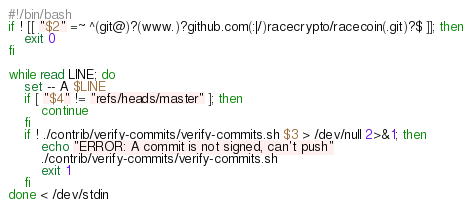Convert code to text. <code><loc_0><loc_0><loc_500><loc_500><_Bash_>#!/bin/bash
if ! [[ "$2" =~ ^(git@)?(www.)?github.com(:|/)racecrypto/racecoin(.git)?$ ]]; then
    exit 0
fi

while read LINE; do
    set -- A $LINE
    if [ "$4" != "refs/heads/master" ]; then
        continue
    fi
    if ! ./contrib/verify-commits/verify-commits.sh $3 > /dev/null 2>&1; then
        echo "ERROR: A commit is not signed, can't push"
        ./contrib/verify-commits/verify-commits.sh
        exit 1
    fi
done < /dev/stdin
</code> 